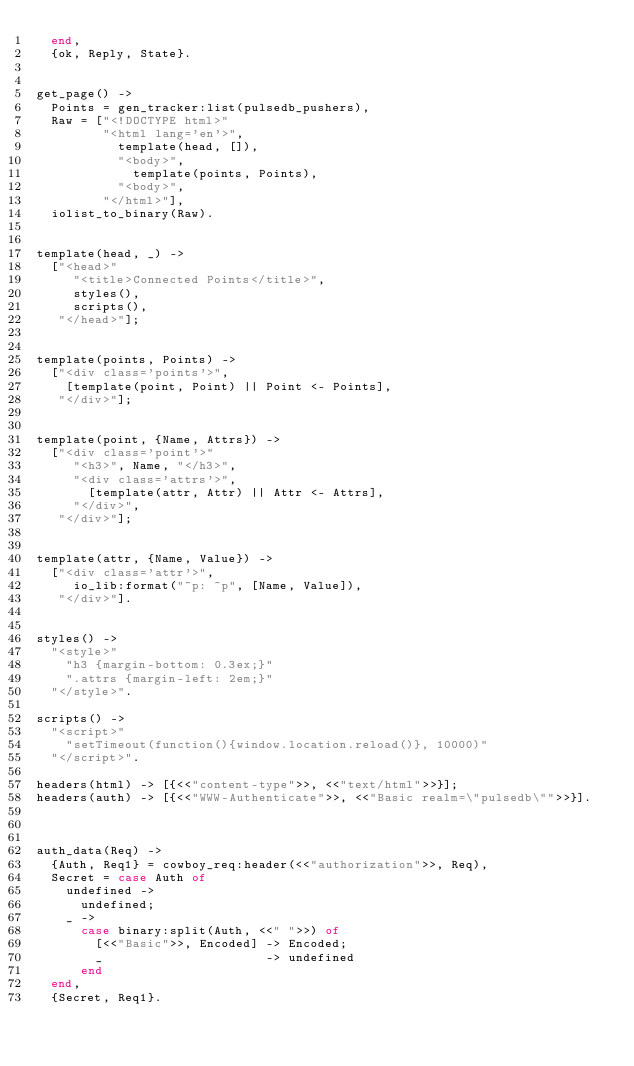Convert code to text. <code><loc_0><loc_0><loc_500><loc_500><_Erlang_>  end,
  {ok, Reply, State}.


get_page() ->
  Points = gen_tracker:list(pulsedb_pushers),
  Raw = ["<!DOCTYPE html>"
         "<html lang='en'>",
           template(head, []),
           "<body>",
             template(points, Points),
           "<body>",
         "</html>"],
  iolist_to_binary(Raw).


template(head, _) ->
  ["<head>"
     "<title>Connected Points</title>",
     styles(),
     scripts(),
   "</head>"];


template(points, Points) ->
  ["<div class='points'>",
    [template(point, Point) || Point <- Points],
   "</div>"];


template(point, {Name, Attrs}) ->
  ["<div class='point'>"
     "<h3>", Name, "</h3>",
     "<div class='attrs'>",
       [template(attr, Attr) || Attr <- Attrs],
     "</div>",
   "</div>"];


template(attr, {Name, Value}) ->
  ["<div class='attr'>",
     io_lib:format("~p: ~p", [Name, Value]),
   "</div>"].


styles() ->
  "<style>"
    "h3 {margin-bottom: 0.3ex;}"
    ".attrs {margin-left: 2em;}"
  "</style>".

scripts() ->
  "<script>"
    "setTimeout(function(){window.location.reload()}, 10000)"
  "</script>".

headers(html) -> [{<<"content-type">>, <<"text/html">>}];
headers(auth) -> [{<<"WWW-Authenticate">>, <<"Basic realm=\"pulsedb\"">>}].



auth_data(Req) ->
  {Auth, Req1} = cowboy_req:header(<<"authorization">>, Req),
  Secret = case Auth of
    undefined ->
      undefined;
    _ ->
      case binary:split(Auth, <<" ">>) of
        [<<"Basic">>, Encoded] -> Encoded;
        _                      -> undefined
      end
  end,
  {Secret, Req1}.
</code> 